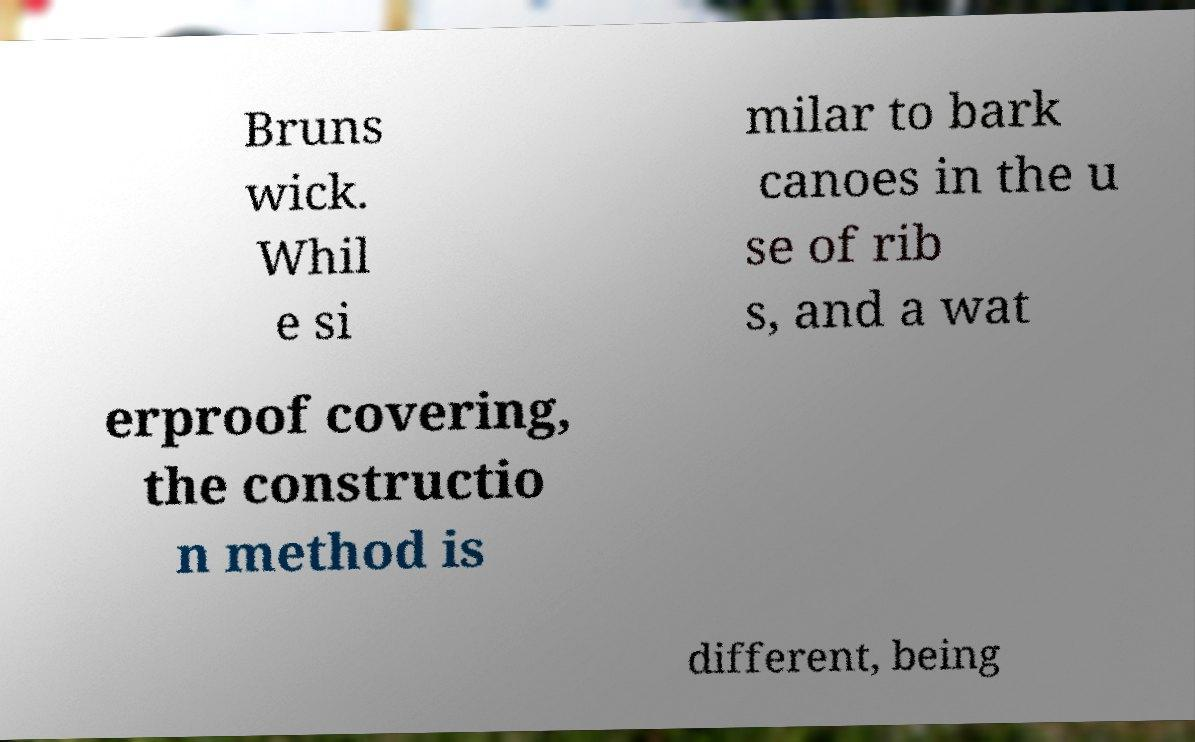Can you read and provide the text displayed in the image?This photo seems to have some interesting text. Can you extract and type it out for me? Bruns wick. Whil e si milar to bark canoes in the u se of rib s, and a wat erproof covering, the constructio n method is different, being 